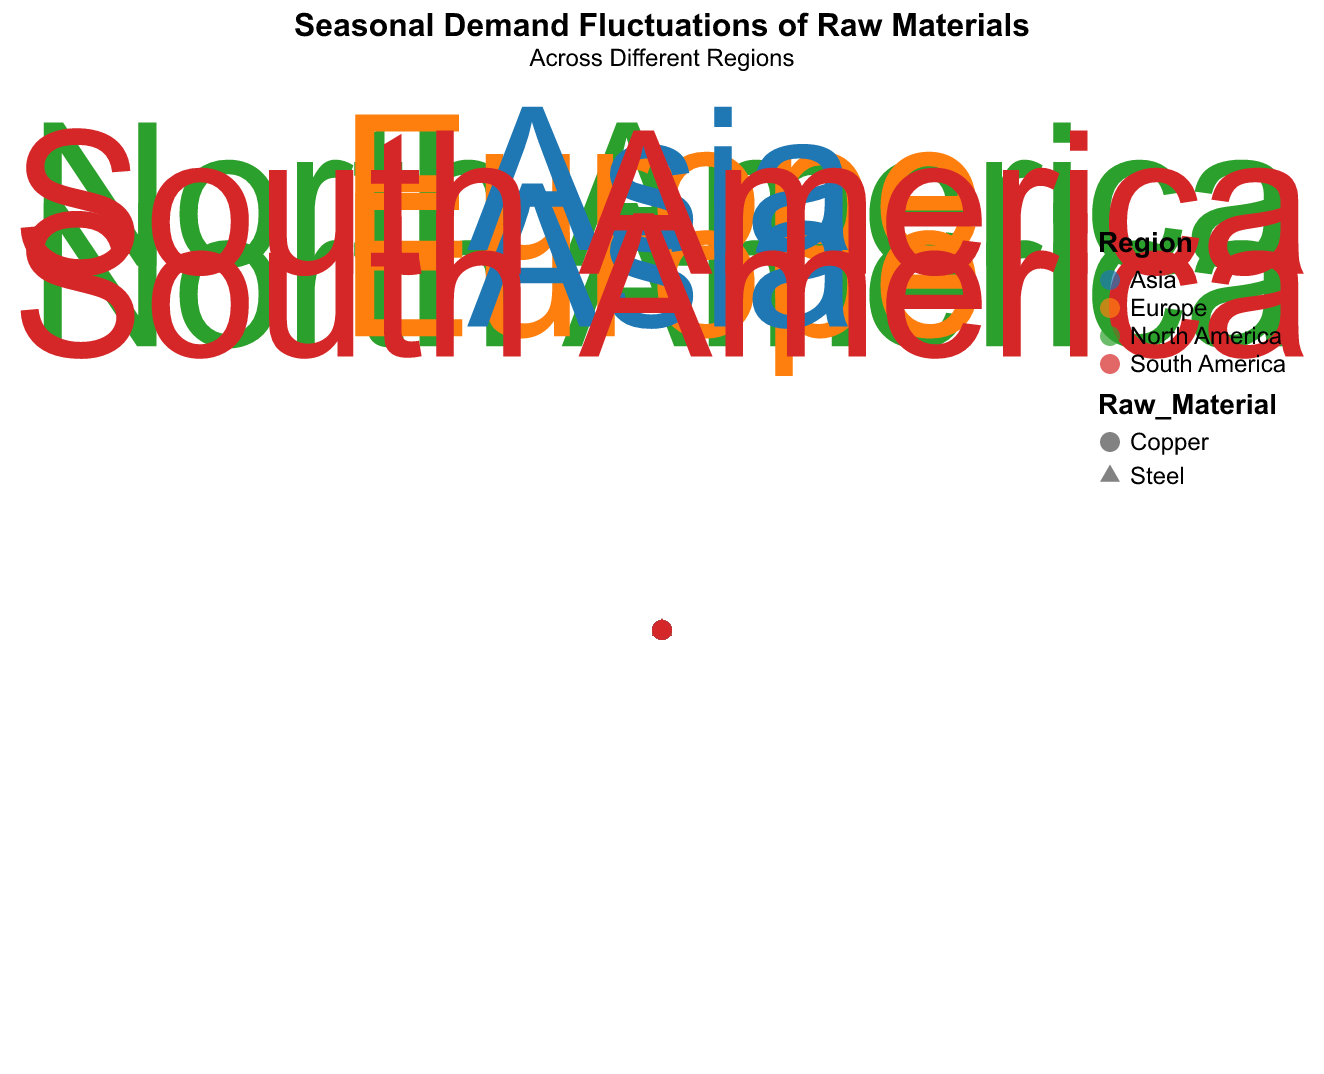What does the title of the chart indicate? The title of the chart is "Seasonal Demand Fluctuations of Raw Materials," with a subtitle "Across Different Regions." This indicates that the chart is visualizing how the demand for various raw materials changes with seasons across different regions.
Answer: Seasonal Demand Fluctuations of Raw Materials Across Different Regions Which raw material and region have the highest demand in May? Looking at the chart, the data points for both Steel and Copper in each region will reveal that Asia has the highest demand for Steel with a quantity of 260 in May.
Answer: Asia, Steel How many data points represent the demand for Copper in January? For Copper in January, each region (North America, Europe, Asia, and South America) will have one data point each. Therefore, there are 4 data points representing the demand for Copper in January.
Answer: 4 Compare the demand for Steel and Copper in Europe during August. Which one is higher? In August, look for the data points representing Steel and Copper in Europe. Steel has a quantity of 190, whereas Copper has a quantity of 120. Thus, the demand for Steel is higher.
Answer: Steel How does the demand for Steel in North America change from January to May? The demand for Steel in North America increases from January (120) to May (240). This can be observed by noting the positions of the data points for these months.
Answer: Increases What is the average demand for Copper in Asia across the given months? The demand for Copper in Asia is 110 in January, 170 in May, and 130 in August. To find the average, add (110 + 170 + 130) which equals 410, then divide by 3, resulting in the average demand of approximately 137.
Answer: 137 Which region has the lowest demand for Steel in January, and what is the quantity? The demand for Steel in January is represented for each region. South America has the lowest quantity at 110.
Answer: South America, 110 How does the demand for Copper in South America in May compare to that in August? The quantity of Copper in South America in May is 140, while in August it is 100. Therefore, the demand decreases from May to August.
Answer: Decreases What shape and color represent Steel in Europe, and what does the size of the shape indicate? Steel is represented by circles. Europe's data points are colored according to the assigned palette for Europe (e.g., likely a specific color like blue), and the size of the shape indicates the quantity of demand, standardized across points.
Answer: Circle, Color for Europe, Quantity Size Which month shows the maximum demand for raw materials across all regions and raw materials? Add up the quantities for all raw materials across all regions in January, May, and August. May has the highest cumulative demand (total for Steel and Copper across regions: North America 390, Europe 410, Asia 430, and South America 370), indicating May has the peak demand.
Answer: May 